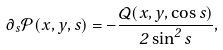Convert formula to latex. <formula><loc_0><loc_0><loc_500><loc_500>\partial _ { s } \mathcal { P } ( x , y , s ) = - \frac { \mathcal { Q } ( x , y , \cos s ) } { 2 \sin ^ { 2 } s } ,</formula> 